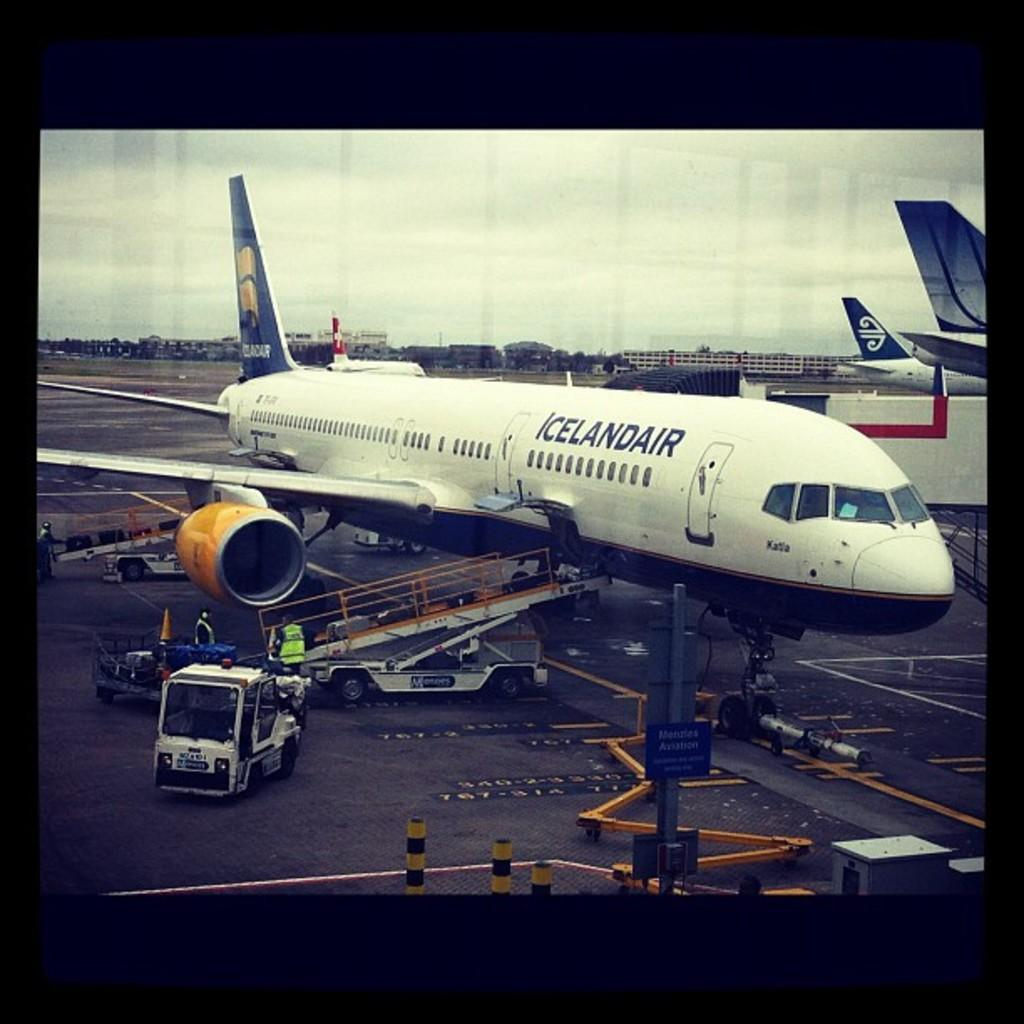What type of transportation can be seen in the image? There are aeroplanes and vehicles on the road in the image. Can you describe the people in the image? There are people in the image, but their specific actions or characteristics are not mentioned in the facts. What else is present in the image besides transportation and people? There are objects, trees, buildings, and clouds in the sky in the background of the image. What type of plants are being used as a visitor's hat in the image? There are no plants or visitors present in the image, so this scenario cannot be observed. 